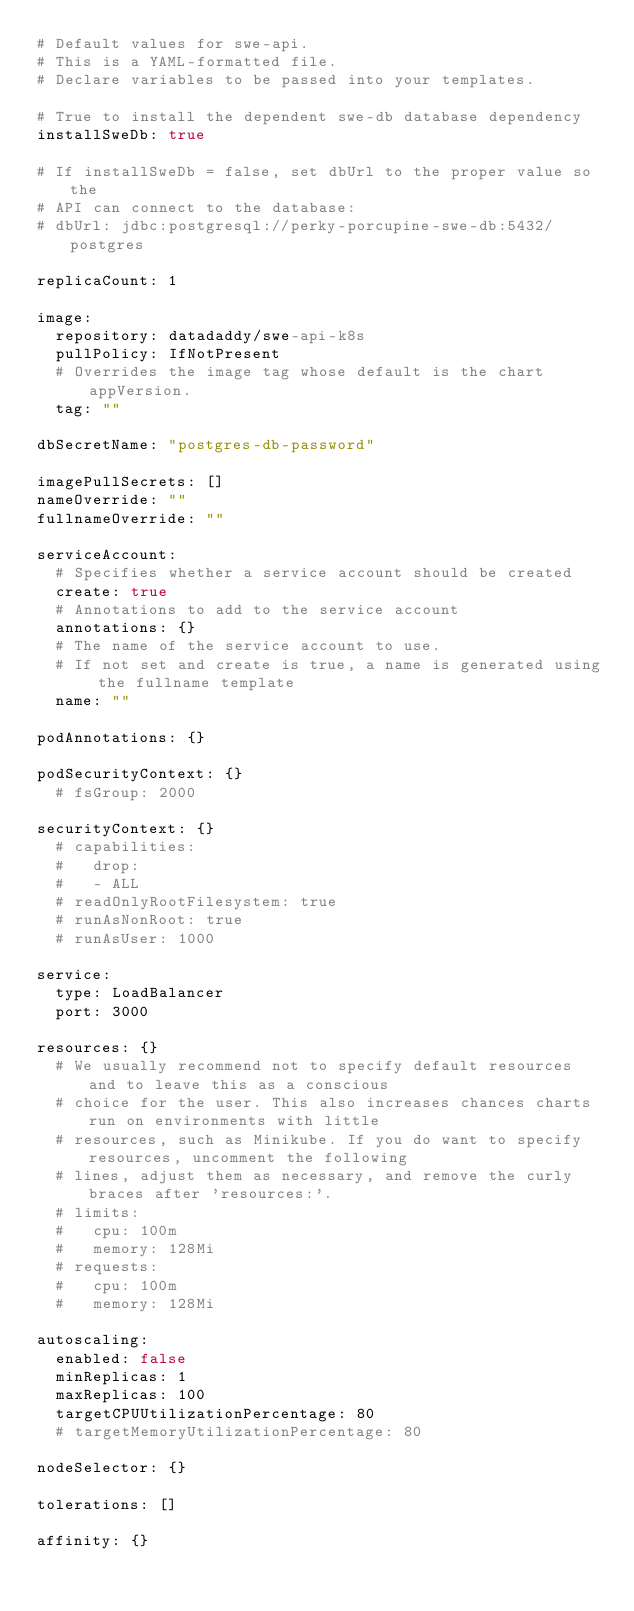<code> <loc_0><loc_0><loc_500><loc_500><_YAML_># Default values for swe-api.
# This is a YAML-formatted file.
# Declare variables to be passed into your templates.

# True to install the dependent swe-db database dependency
installSweDb: true

# If installSweDb = false, set dbUrl to the proper value so the
# API can connect to the database:
# dbUrl: jdbc:postgresql://perky-porcupine-swe-db:5432/postgres

replicaCount: 1

image:
  repository: datadaddy/swe-api-k8s
  pullPolicy: IfNotPresent
  # Overrides the image tag whose default is the chart appVersion.
  tag: ""

dbSecretName: "postgres-db-password"

imagePullSecrets: []
nameOverride: ""
fullnameOverride: ""

serviceAccount:
  # Specifies whether a service account should be created
  create: true
  # Annotations to add to the service account
  annotations: {}
  # The name of the service account to use.
  # If not set and create is true, a name is generated using the fullname template
  name: ""

podAnnotations: {}

podSecurityContext: {}
  # fsGroup: 2000

securityContext: {}
  # capabilities:
  #   drop:
  #   - ALL
  # readOnlyRootFilesystem: true
  # runAsNonRoot: true
  # runAsUser: 1000

service:
  type: LoadBalancer
  port: 3000

resources: {}
  # We usually recommend not to specify default resources and to leave this as a conscious
  # choice for the user. This also increases chances charts run on environments with little
  # resources, such as Minikube. If you do want to specify resources, uncomment the following
  # lines, adjust them as necessary, and remove the curly braces after 'resources:'.
  # limits:
  #   cpu: 100m
  #   memory: 128Mi
  # requests:
  #   cpu: 100m
  #   memory: 128Mi

autoscaling:
  enabled: false
  minReplicas: 1
  maxReplicas: 100
  targetCPUUtilizationPercentage: 80
  # targetMemoryUtilizationPercentage: 80

nodeSelector: {}

tolerations: []

affinity: {}
</code> 